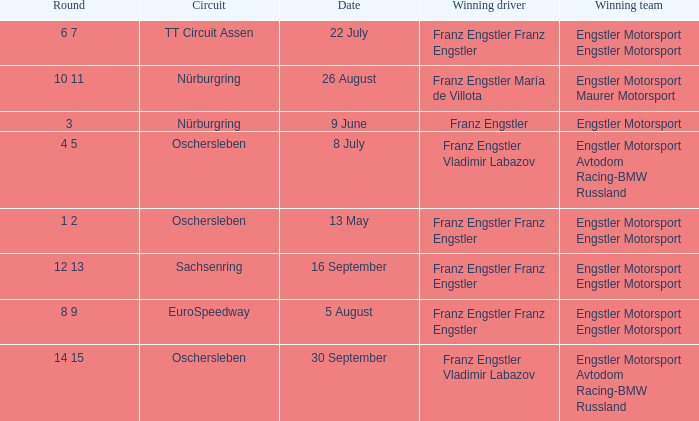Who is the Winning Driver that has a Winning team of Engstler Motorsport Engstler Motorsport and also the Date 22 July? Franz Engstler Franz Engstler. 